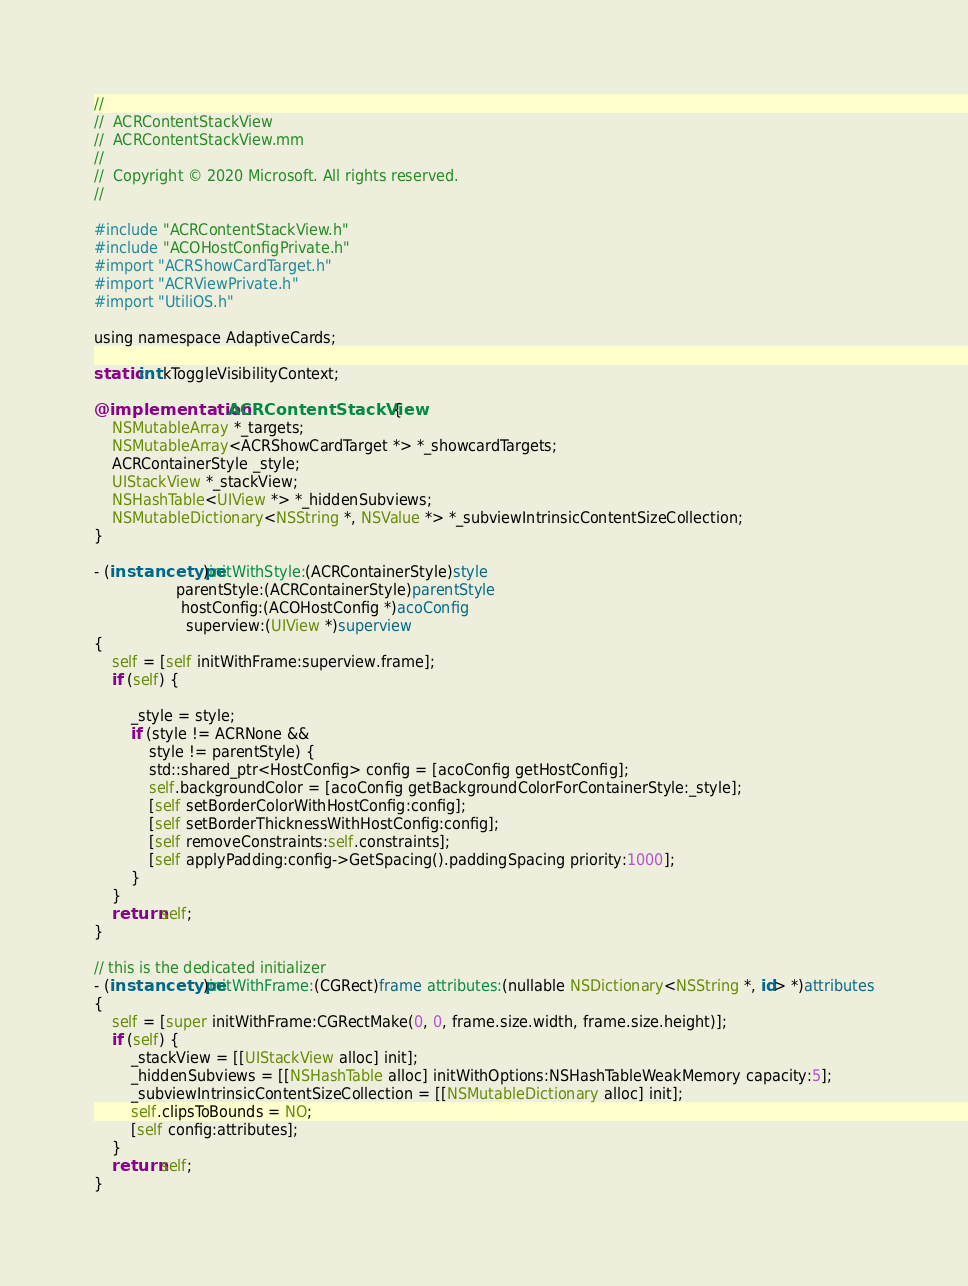<code> <loc_0><loc_0><loc_500><loc_500><_ObjectiveC_>//
//  ACRContentStackView
//  ACRContentStackView.mm
//
//  Copyright © 2020 Microsoft. All rights reserved.
//

#include "ACRContentStackView.h"
#include "ACOHostConfigPrivate.h"
#import "ACRShowCardTarget.h"
#import "ACRViewPrivate.h"
#import "UtiliOS.h"

using namespace AdaptiveCards;

static int kToggleVisibilityContext;

@implementation ACRContentStackView {
    NSMutableArray *_targets;
    NSMutableArray<ACRShowCardTarget *> *_showcardTargets;
    ACRContainerStyle _style;
    UIStackView *_stackView;
    NSHashTable<UIView *> *_hiddenSubviews;
    NSMutableDictionary<NSString *, NSValue *> *_subviewIntrinsicContentSizeCollection;
}

- (instancetype)initWithStyle:(ACRContainerStyle)style
                  parentStyle:(ACRContainerStyle)parentStyle
                   hostConfig:(ACOHostConfig *)acoConfig
                    superview:(UIView *)superview
{
    self = [self initWithFrame:superview.frame];
    if (self) {

        _style = style;
        if (style != ACRNone &&
            style != parentStyle) {
            std::shared_ptr<HostConfig> config = [acoConfig getHostConfig];
            self.backgroundColor = [acoConfig getBackgroundColorForContainerStyle:_style];
            [self setBorderColorWithHostConfig:config];
            [self setBorderThicknessWithHostConfig:config];
            [self removeConstraints:self.constraints];
            [self applyPadding:config->GetSpacing().paddingSpacing priority:1000];
        }
    }
    return self;
}

// this is the dedicated initializer
- (instancetype)initWithFrame:(CGRect)frame attributes:(nullable NSDictionary<NSString *, id> *)attributes
{
    self = [super initWithFrame:CGRectMake(0, 0, frame.size.width, frame.size.height)];
    if (self) {
        _stackView = [[UIStackView alloc] init];
        _hiddenSubviews = [[NSHashTable alloc] initWithOptions:NSHashTableWeakMemory capacity:5];
        _subviewIntrinsicContentSizeCollection = [[NSMutableDictionary alloc] init];
        self.clipsToBounds = NO;
        [self config:attributes];
    }
    return self;
}
</code> 